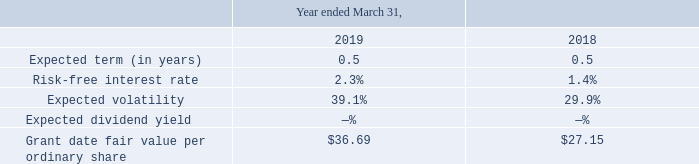Employee Share Purchase Plan (ESPP)
The Company estimates the fair value of its ESPP share options on the date of grant using the Black-Scholes option-pricing model, which requires the use of highly subjective estimates and assumptions. The Company estimates the expected term of ESPP share options based on the length of each offering period, which is six months.
The risk-free interest rate is based on a treasury instrument whose term is consistent with the expected life of the ESPP share option. Expected volatility is based on the Company’s historical volatility. The Company uses an expected dividend rate of zero as it currently has no history or expectation of paying dividends on its ordinary shares.
The grant date fair value per ordinary share is based on the closing market value of its ordinary shares on the first day of each ESPP offering period. The first authorized offering period under the ESPP commenced on July 1, 2017.
The fair value of each ESPP option grant was estimated using the Black-Scholes option-pricing model that used the following weighted-average assumptions:
The weighted-average per share fair value of ESPP share options granted to employees during the years ended March 31, 2019 and 2018, was $9.58 and $6.41, respectively.
Which model is used to estimate fair value of its ESPP share options on the date of grant ? Black-scholes option-pricing model. What is the risk free interest rate based on? A treasury instrument whose term is consistent with the expected life of the espp share option. What was the Expected term (in years) in 2019 and 2018 respectively? 0.5, 0.5. What was the change in the Risk-free interest rate from 2018 to 2019?
Answer scale should be: percent. 2.3 - 1.4
Answer: 0.9. What is the average Expected volatility for 2018 and 2019?
Answer scale should be: percent. (39.1 + 29.9) / 2
Answer: 34.5. In which year was the Grant date fair value per ordinary share less than 30.0? Locate and analyze grant date fair value per ordinary share in row 7
answer: 2018. 